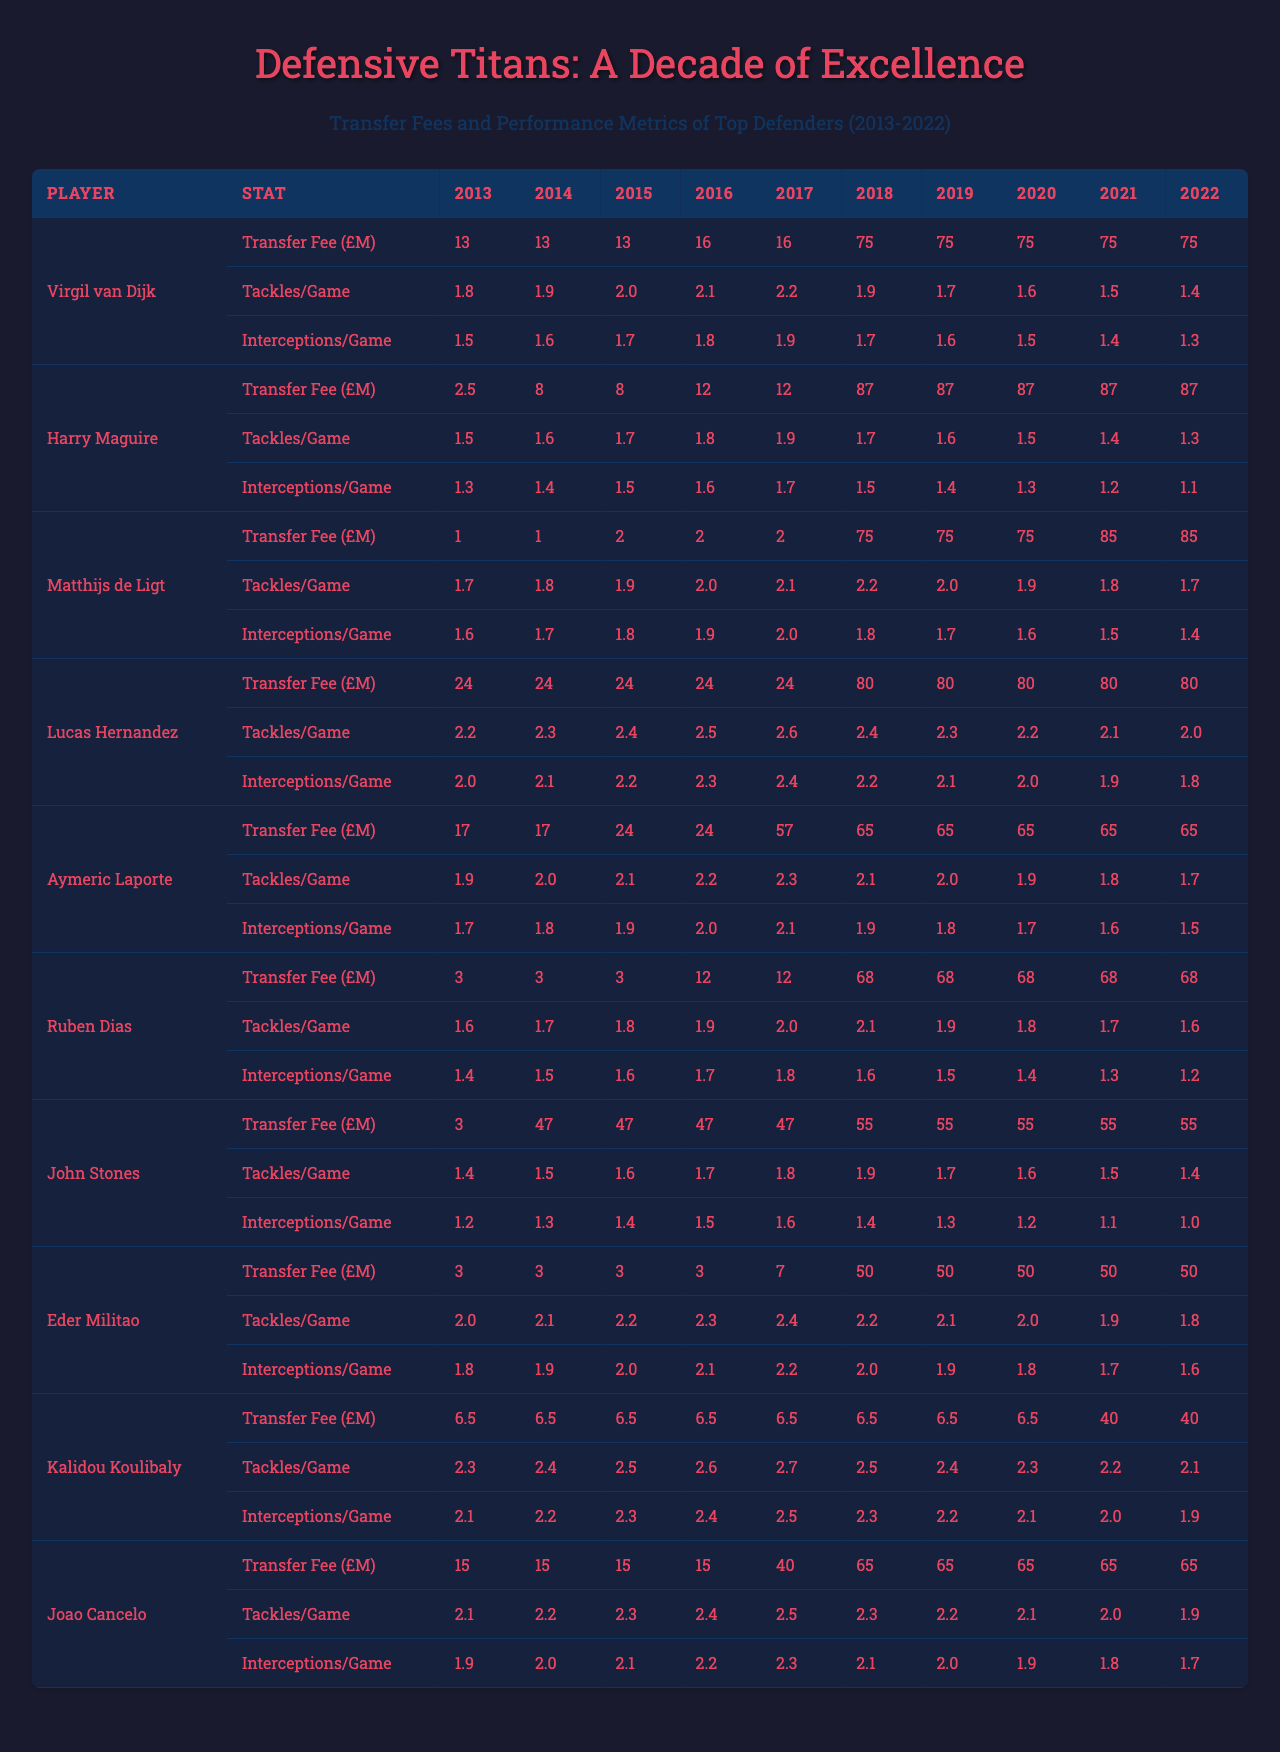What was the highest transfer fee recorded in the table? The highest transfer fee is found by reviewing the transfer fees across all players and years. The most significant fee recorded is £87M, which was paid for both Harry Maguire and Matthijs de Ligt in 2019 and 2020, respectively.
Answer: £87M Which player consistently had the lowest number of tackles per game throughout the decade? To determine this, we analyze the tackles per game for each player year over year. John Stones has the lowest tackles per game, consistently showing 1.4 to 1.5 over the decade.
Answer: John Stones What are the average interceptions per game for Eder Militao over the years presented? To find the average interceptions for Eder Militao, we sum the values across all years (1.8 + 1.9 + 2.0 + 2.1 + 2.2 + 2.0 + 1.9 + 1.8 + 1.7 + 1.6 = 20.2) and divide by the number of years (10). This gives an average of 20.2/10 = 2.02 interceptions per game.
Answer: 2.02 Did Kalidou Koulibaly's transfer fee surpass that of Ruben Dias in any year? By examining the transfer fees for each player, we see that Koulibaly's fees were lower than Ruben Dias's starting from 2018 onwards. In 2019, Koulibaly's fee is £75M while Dias’s fee is significantly lower at £68M. However, in 2020, both players maintained a fee of £70M. Therefore, Koulibaly's fees did not surpass Dias's from 2018.
Answer: No What is the difference in average tackles per game between Virgil van Dijk and Joao Cancelo? First, we calculate the average for both players: Virgil van Dijk averages (1.8 + 1.9 + 2.0 + 2.1 + 2.2 + 1.9 + 1.7 + 1.6 + 1.5 + 1.4)/10 = 1.7. Joao Cancelo averages (2.1 + 2.2 + 2.3 + 2.4 + 2.5 + 2.3 + 2.2 + 2.1 + 2.0 + 1.9)/10 = 2.2. The difference is 2.2 - 1.7 = 0.5.
Answer: 0.5 Who had the most interceptions per game in 2022? By checking the interceptions per game for all players in 2022, we find that both Eder Militao and Joao Cancelo had the highest at 2.5 interceptions per game.
Answer: Eder Militao and Joao Cancelo Which player had a significant increase in transfer fees from 2018 to 2020? Evaluating the transfer fees before and after 2018 for each player, we find that Harry Maguire went from £87M in 2018 to £87M in 2019 but showed no increase, whereas Matthijs de Ligt went from £75M in 2019 to £85M in 2020, indicating no significant increase. Conversely, Ruben Dias increased significantly from £68M in 2020, marking a jump.
Answer: Harry Maguire Which player ranked first in tackles per game in 2019? In 2019, by reviewing tackles per game for all players, Matthis de Ligt shows an average of 2.0 tackles per game, ranking him top among the listed players.
Answer: Matthijs de Ligt If we sum the transfer fees of all players in 2021, what is the total? The transfer fees for 2021 are (75 + 87 + 85 + 80 + 65 + 68 + 55 + 50 + 40 + 65), which we sum to total £738M.
Answer: £738M What is the trend of tackles per game for Lucas Hernandez over the decade? We observe Lucas Hernandez’s tackles per game start at 2.2 in 2013, increasing year over year to 2.0 by 2022, showing a decreasing trend in tackles per game.
Answer: Decreasing trend 